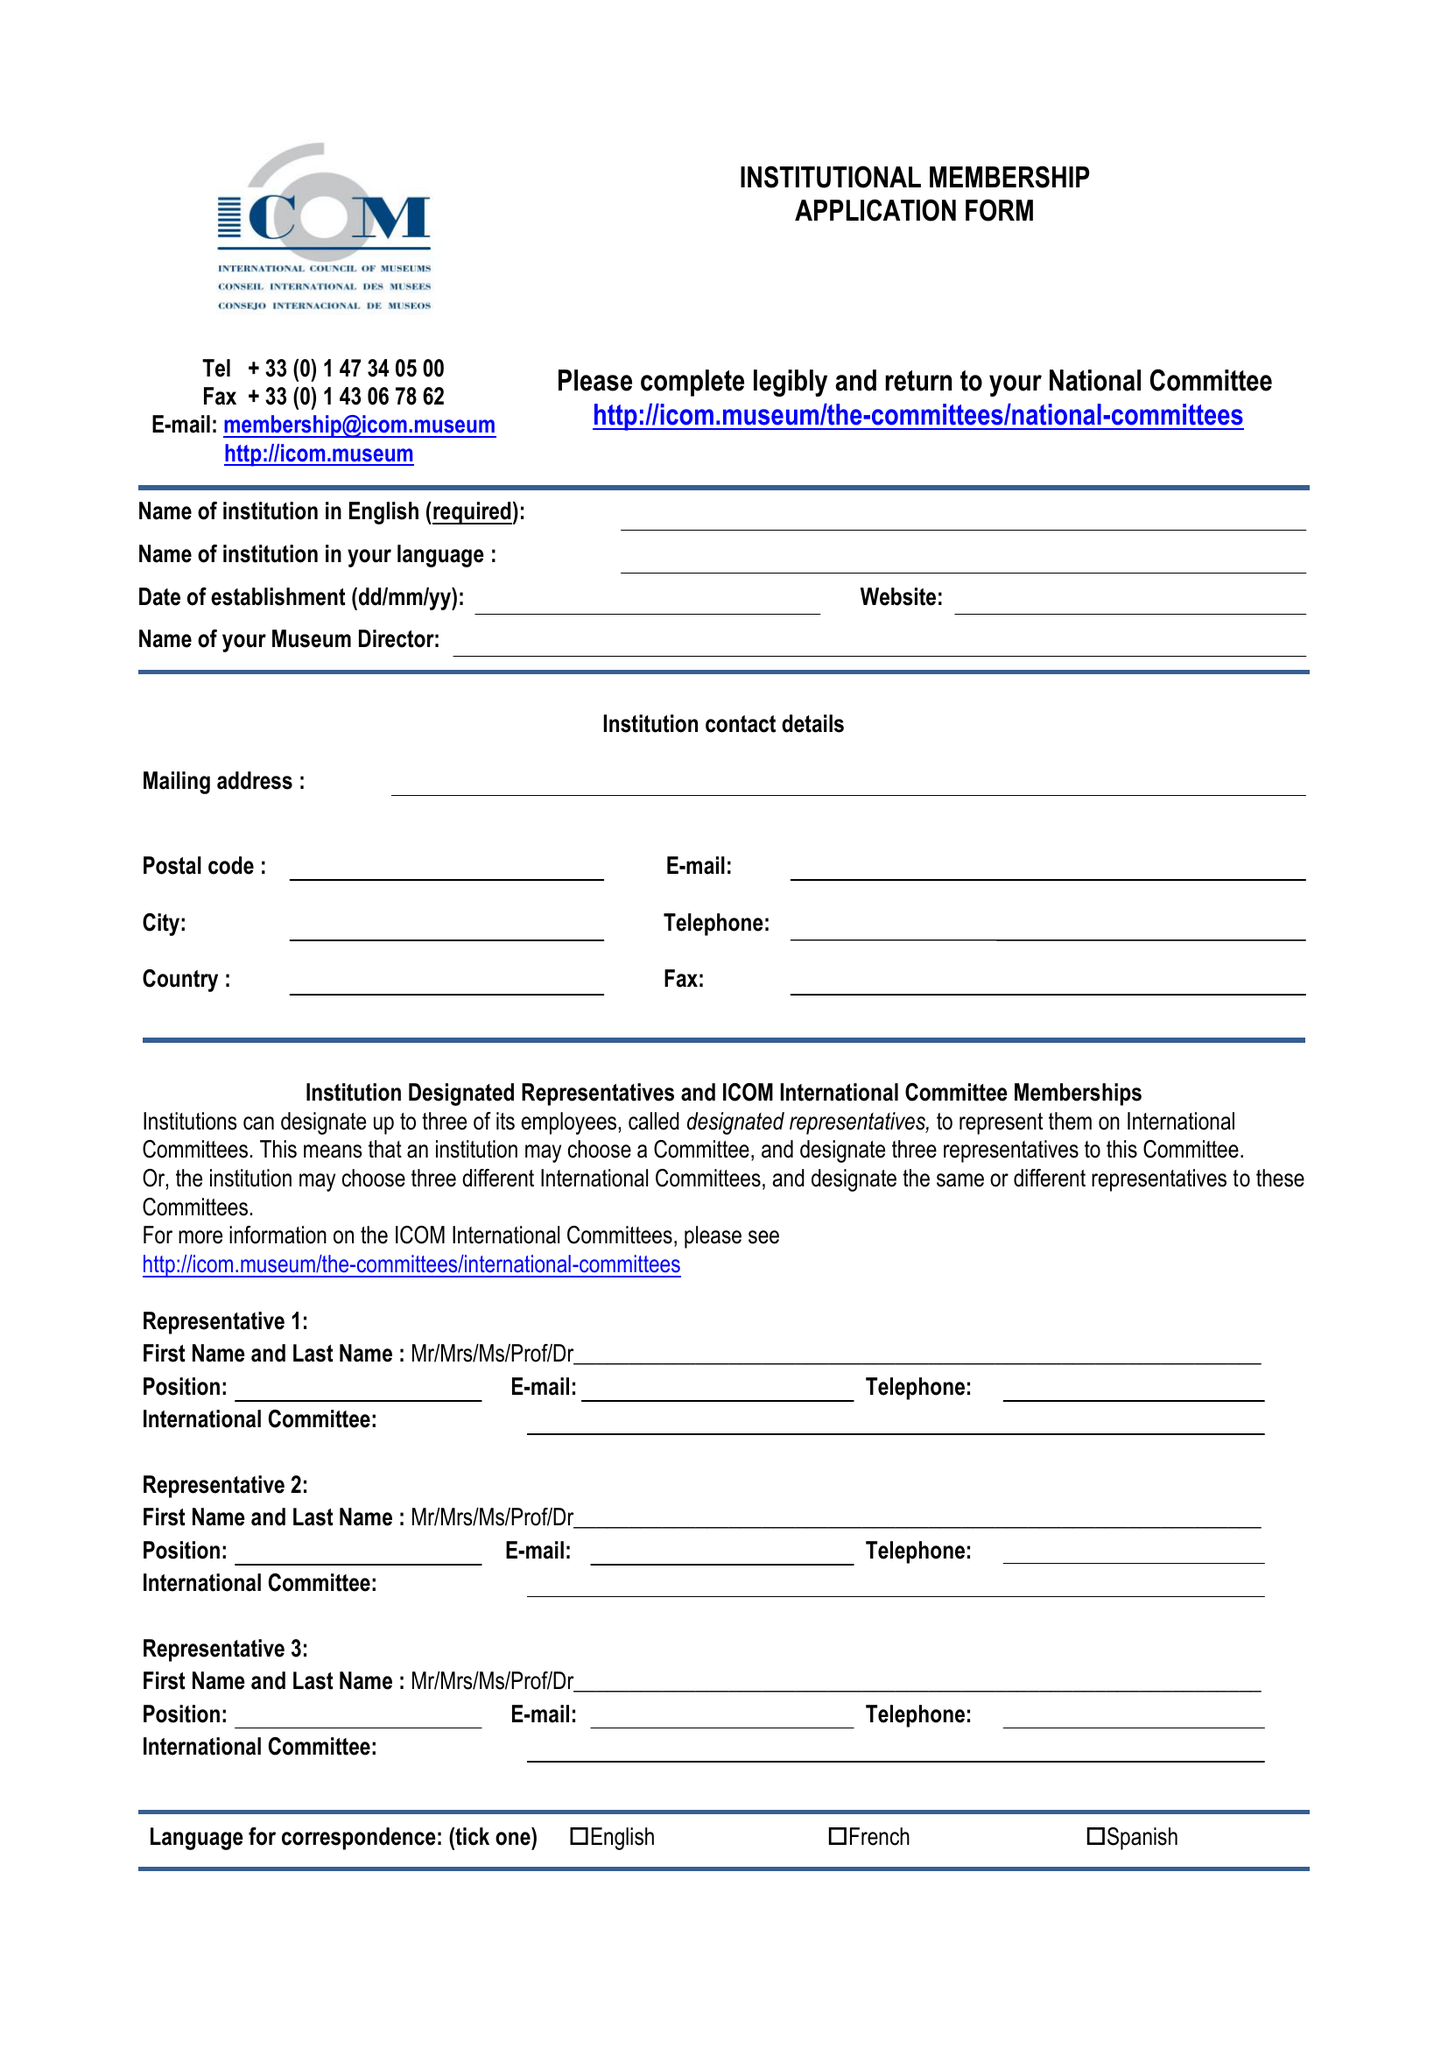What is the value for the address__post_town?
Answer the question using a single word or phrase. LONDON 